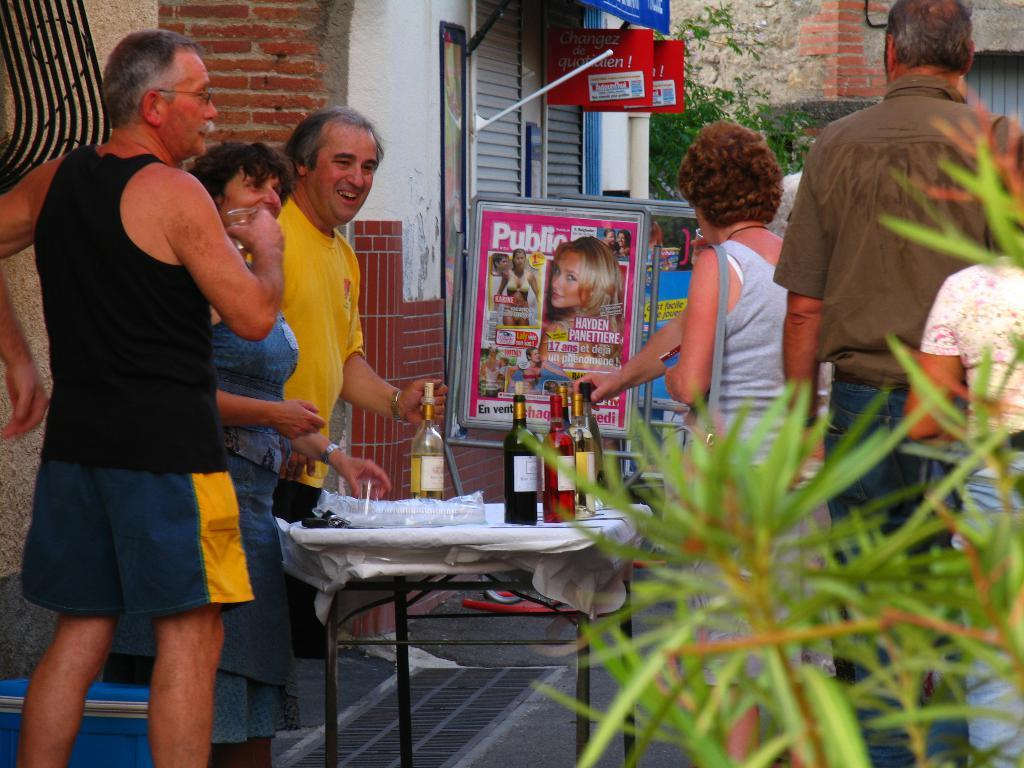<image>
Offer a succinct explanation of the picture presented. A group of people are gathered by an outdoor table with bottles of wine on it and a sign that says Public. 